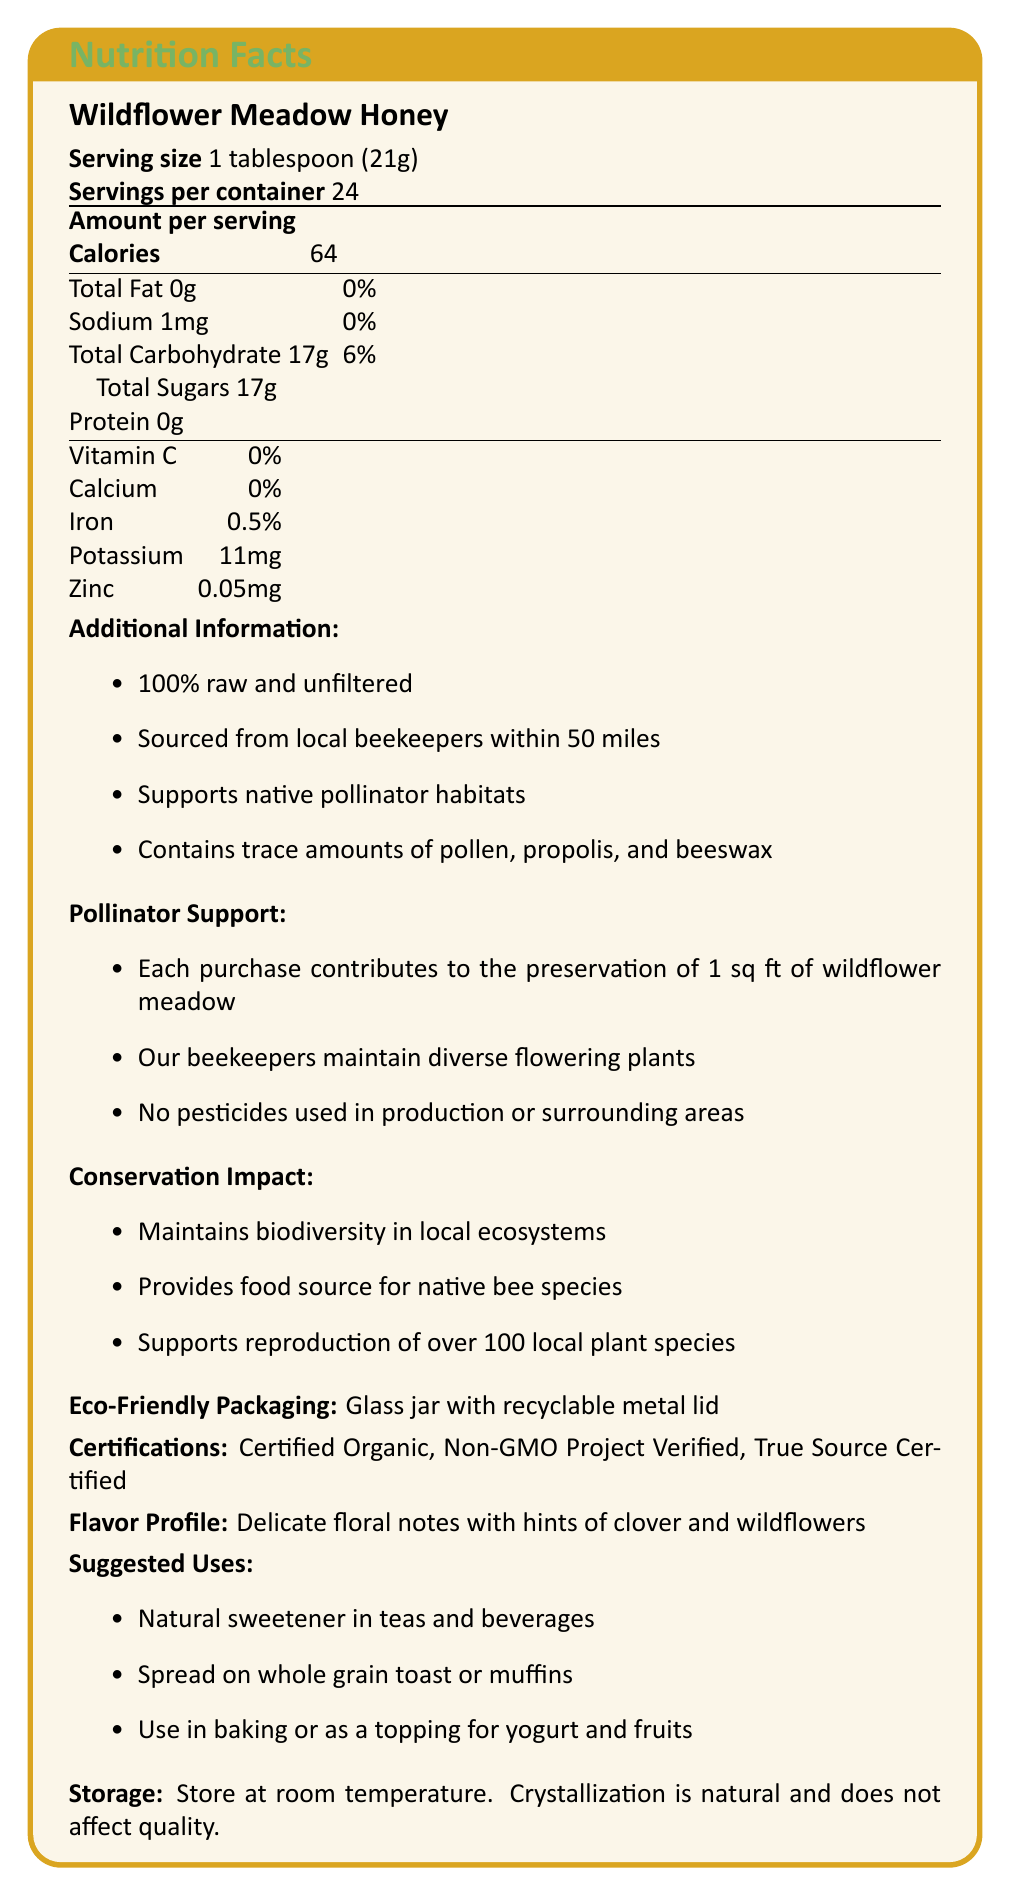what is the serving size of the Wildflower Meadow Honey? The document states "Serving size 1 tablespoon (21g)" under the product name.
Answer: 1 tablespoon (21g) how many calories are there per serving? The document clearly lists "Calories 64" under the "Amount per serving" section.
Answer: 64 what percentage of daily iron is provided by one serving? The document lists iron as 0.5% under the nutrient breakdown.
Answer: 0.5% what additional components does the honey contain besides honey? The additional information section mentions "Contains trace amounts of pollen, propolis, and beeswax."
Answer: Trace amounts of pollen, propolis, and beeswax what is the source of the honey? The additional details section specifies "Sourced from local beekeepers within 50 miles."
Answer: Local beekeepers within 50 miles which of the following certifications is NOT listed on the label: A. USDA Organic B. Certified Organic C. Non-GMO Project Verified D. True Source Certified The document lists "Certified Organic, Non-GMO Project Verified, True Source Certified" but does not include "USDA Organic."
Answer: A. USDA Organic how much sodium is there per serving? A. 1mg B. 2mg C. 5mg D. 10mg The document lists "Sodium 1mg" under the nutrient breakdown.
Answer: A. 1mg is there any protein in the Wildflower Meadow Honey? The nutrient breakdown shows "Protein 0g."
Answer: No does purchasing this honey help with pollinator habitats? The pollinator support section mentions, "Each purchase contributes to the preservation of 1 sq ft of wildflower meadow."
Answer: Yes summarize the main ideas of the document. The document provides comprehensive nutritional information about the Wildflower Meadow Honey, highlighting its benefits to local pollinator habitats and biodiversity, eco-friendly packaging, and certifications like Certified Organic and Non-GMO Project Verified.
Answer: The document outlines nutritional information and additional benefits of Wildflower Meadow Honey. Key features include being 100% raw and unfiltered, sourced locally, and supporting pollinator habitats and local biodiversity. It also mentions the eco-friendly packaging and various certifications. what is the flavor profile of the honey? The document lists the flavor profile under the flavor profile section.
Answer: Delicate floral notes with hints of clover and wildflowers how does the honey help support biodiversity in local ecosystems? The conservation impact section mentions, "Helps maintain biodiversity in local ecosystems" and other supportive actions.
Answer: Helps maintain biodiversity in local ecosystems, supports the reproduction of over 100 local plant species, and provides an essential food source for native bee species. what should you do if the honey crystallizes? The storage instructions state, "Crystallization is natural and does not affect quality."
Answer: Store at room temperature. Crystallization is natural and does not affect quality. which local plant species specifically benefit from this honey? The document mentions "supports the reproduction of over 100 local plant species," but does not list specific plant species.
Answer: Not enough information 